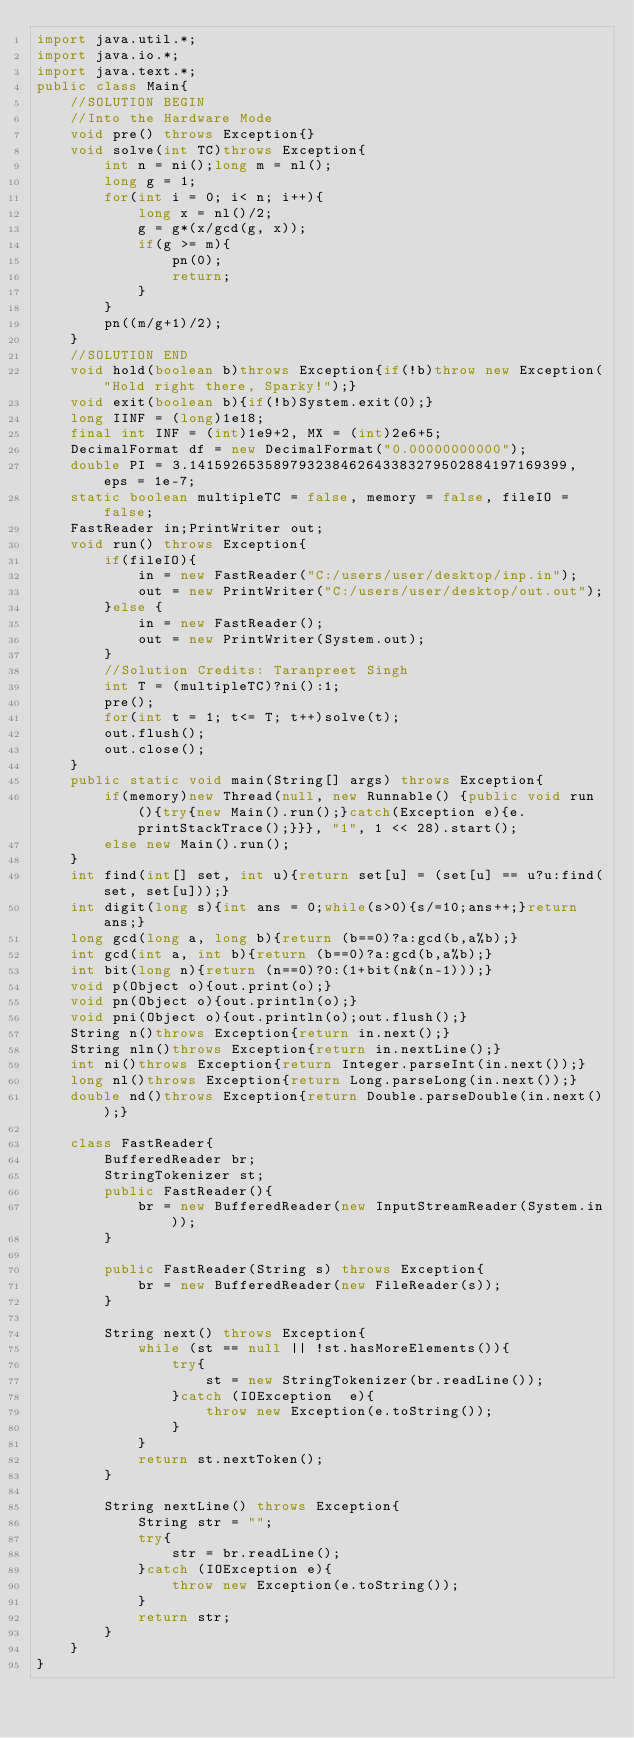<code> <loc_0><loc_0><loc_500><loc_500><_Java_>import java.util.*;
import java.io.*;
import java.text.*;
public class Main{
    //SOLUTION BEGIN
    //Into the Hardware Mode
    void pre() throws Exception{}
    void solve(int TC)throws Exception{
        int n = ni();long m = nl();
        long g = 1;
        for(int i = 0; i< n; i++){
            long x = nl()/2;
            g = g*(x/gcd(g, x));
            if(g >= m){
                pn(0);
                return;
            }
        }
        pn((m/g+1)/2);
    }
    //SOLUTION END
    void hold(boolean b)throws Exception{if(!b)throw new Exception("Hold right there, Sparky!");}
    void exit(boolean b){if(!b)System.exit(0);}
    long IINF = (long)1e18;
    final int INF = (int)1e9+2, MX = (int)2e6+5;
    DecimalFormat df = new DecimalFormat("0.00000000000");
    double PI = 3.141592653589793238462643383279502884197169399, eps = 1e-7;
    static boolean multipleTC = false, memory = false, fileIO = false;
    FastReader in;PrintWriter out;
    void run() throws Exception{
        if(fileIO){
            in = new FastReader("C:/users/user/desktop/inp.in");
            out = new PrintWriter("C:/users/user/desktop/out.out");
        }else {
            in = new FastReader();
            out = new PrintWriter(System.out);
        }
        //Solution Credits: Taranpreet Singh
        int T = (multipleTC)?ni():1;
        pre();
        for(int t = 1; t<= T; t++)solve(t);
        out.flush();
        out.close();
    }
    public static void main(String[] args) throws Exception{
        if(memory)new Thread(null, new Runnable() {public void run(){try{new Main().run();}catch(Exception e){e.printStackTrace();}}}, "1", 1 << 28).start();
        else new Main().run();
    }
    int find(int[] set, int u){return set[u] = (set[u] == u?u:find(set, set[u]));}
    int digit(long s){int ans = 0;while(s>0){s/=10;ans++;}return ans;}
    long gcd(long a, long b){return (b==0)?a:gcd(b,a%b);}
    int gcd(int a, int b){return (b==0)?a:gcd(b,a%b);}
    int bit(long n){return (n==0)?0:(1+bit(n&(n-1)));}
    void p(Object o){out.print(o);}
    void pn(Object o){out.println(o);}
    void pni(Object o){out.println(o);out.flush();}
    String n()throws Exception{return in.next();}
    String nln()throws Exception{return in.nextLine();}
    int ni()throws Exception{return Integer.parseInt(in.next());}
    long nl()throws Exception{return Long.parseLong(in.next());}
    double nd()throws Exception{return Double.parseDouble(in.next());}

    class FastReader{
        BufferedReader br;
        StringTokenizer st;
        public FastReader(){
            br = new BufferedReader(new InputStreamReader(System.in));
        }

        public FastReader(String s) throws Exception{
            br = new BufferedReader(new FileReader(s));
        }

        String next() throws Exception{
            while (st == null || !st.hasMoreElements()){
                try{
                    st = new StringTokenizer(br.readLine());
                }catch (IOException  e){
                    throw new Exception(e.toString());
                }
            }
            return st.nextToken();
        }

        String nextLine() throws Exception{
            String str = "";
            try{   
                str = br.readLine();	
            }catch (IOException e){
                throw new Exception(e.toString());
            }  
            return str;
        }
    }   
}</code> 